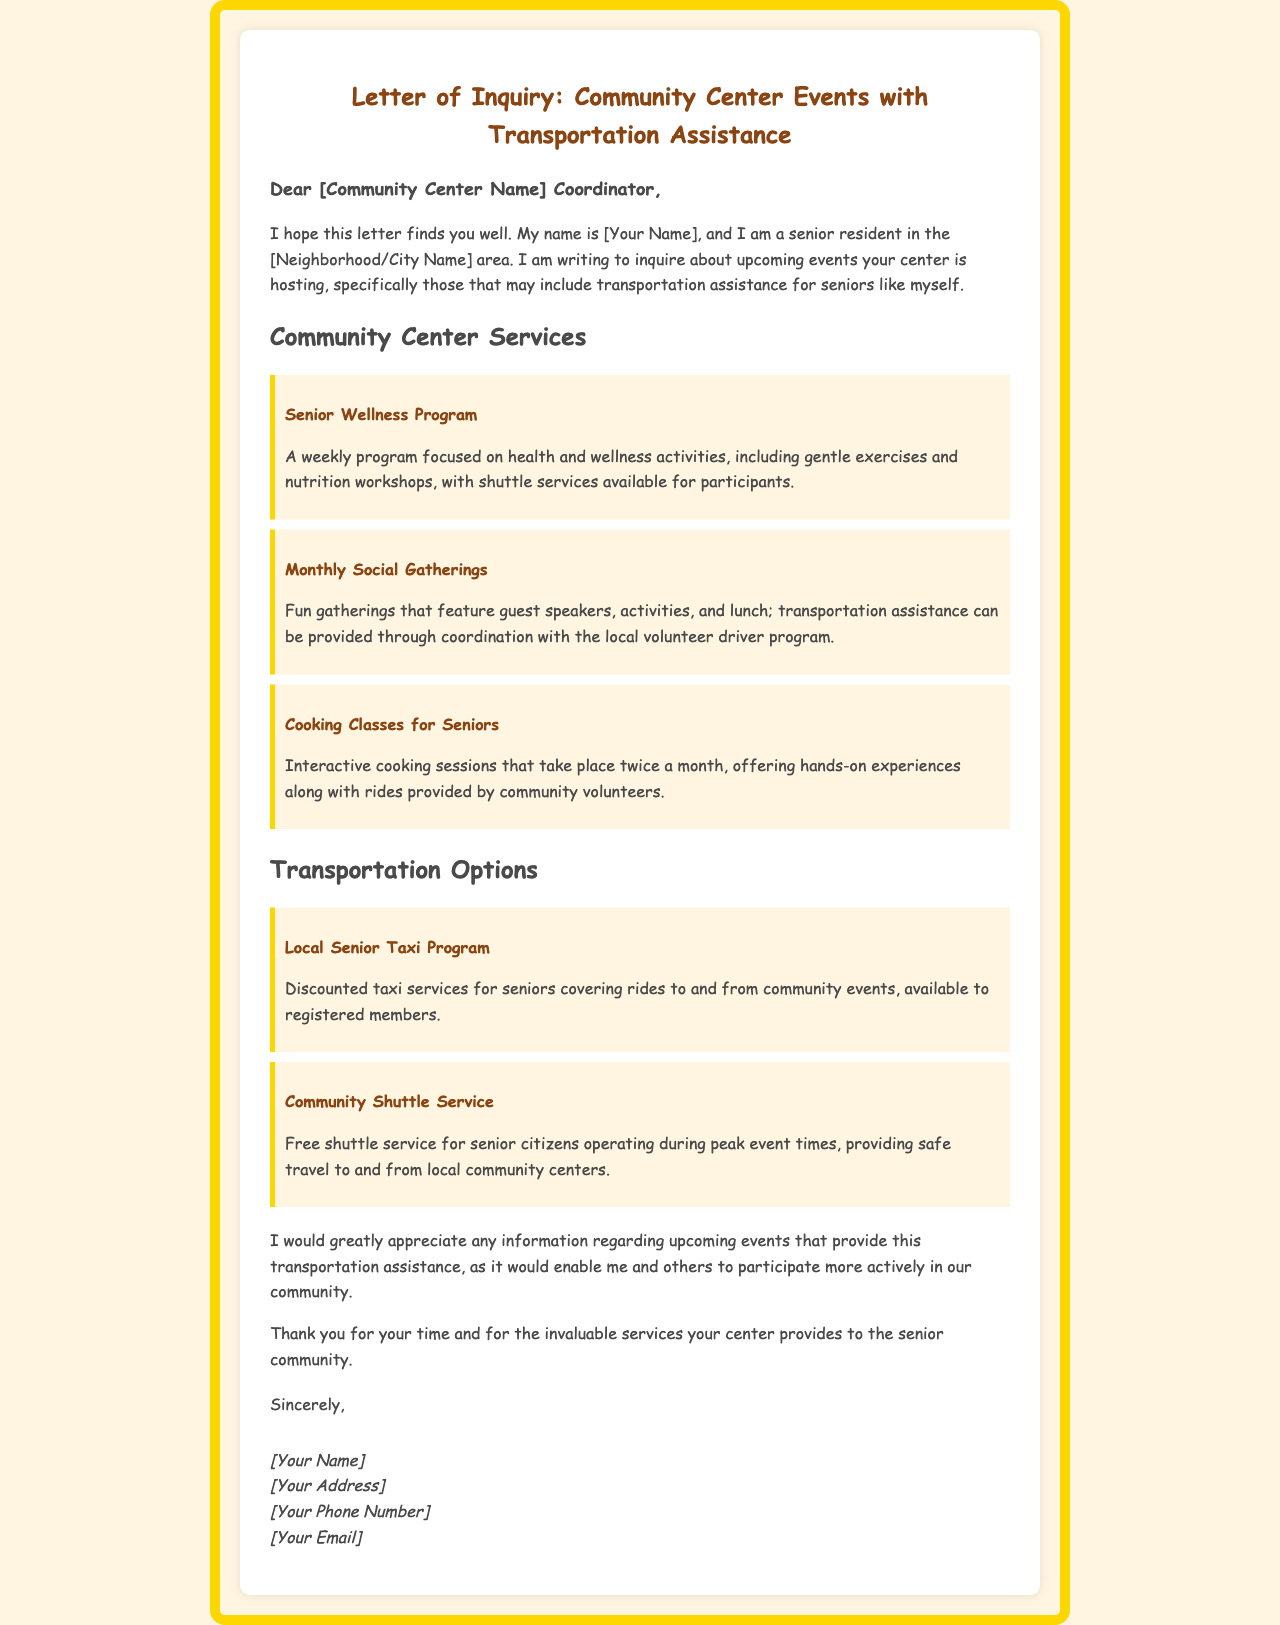What is the title of the letter? The title of the letter indicates the purpose of the correspondence, which is to inquire about community events with transportation assistance.
Answer: Letter of Inquiry: Community Center Events with Transportation Assistance Who is the intended audience of the letter? The letter is addressed to a specific group responsible for managing community events, indicating who it is meant for.
Answer: Community Center Coordinator What services are highlighted for seniors? The letter outlines various programs available for seniors, allowing for understanding of provided benefits.
Answer: Senior Wellness Program, Monthly Social Gatherings, Cooking Classes for Seniors What is one example of transportation assistance mentioned? The letter mentions specific programs that help seniors with transportation, showcasing the options available.
Answer: Local Senior Taxi Program How often do cooking classes for seniors take place? This question addresses the frequency of a specific event, which is provided in the letter.
Answer: Twice a month What does the community shuttle service provide? This question seeks to clarify what the shuttle service offers to seniors, mentioned in the transportation options section.
Answer: Free shuttle service Who is the author of the letter? The letter includes a signature section where the author identifies themselves, crucial for understanding the sender's identity.
Answer: [Your Name] What type of events is the author inquiring about? The letter seeks specific details about events that include features beneficial for seniors, indicating the focus of the inquiry.
Answer: Upcoming events with transportation assistance What is the color of the letter's background? This question addresses the design aspect of the letter, relevant for understanding its presentation.
Answer: #FFF5E1 